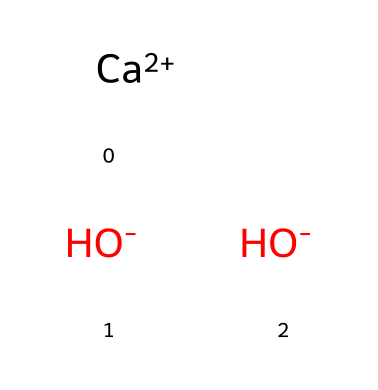What is the name of this chemical? The SMILES representation indicates it consists of calcium and hydroxide ions. This combination is known as calcium hydroxide.
Answer: calcium hydroxide How many hydroxide ions are present in this structure? The SMILES notation shows two separate hydroxide ions ([OH-]), indicating that there are two hydroxide ions in total.
Answer: 2 What ion carries a positive charge in this compound? The SMILES representation shows [Ca+2], indicating that the calcium ion has a positive charge.
Answer: calcium What type of compound is calcium hydroxide? Calcium hydroxide consists of a metal ion (calcium) and hydroxide ions, categorizing it as a base.
Answer: base What is the total number of atoms in this chemical structure? The structure includes one calcium atom and two hydroxide units, each containing one oxygen and one hydrogen atom, giving a total of 1 (Ca) + 2 (O) + 2 (H) = 5 atoms.
Answer: 5 What properties of calcium hydroxide make it suitable for water treatment? Calcium hydroxide is a strong base that can react with acids and help in neutralization, as well as removing impurities from water.
Answer: strong base How does calcium hydroxide affect the pH of water? When dissolved, it releases hydroxide ions into the solution, which increases the pH, making the water more basic.
Answer: increases pH 